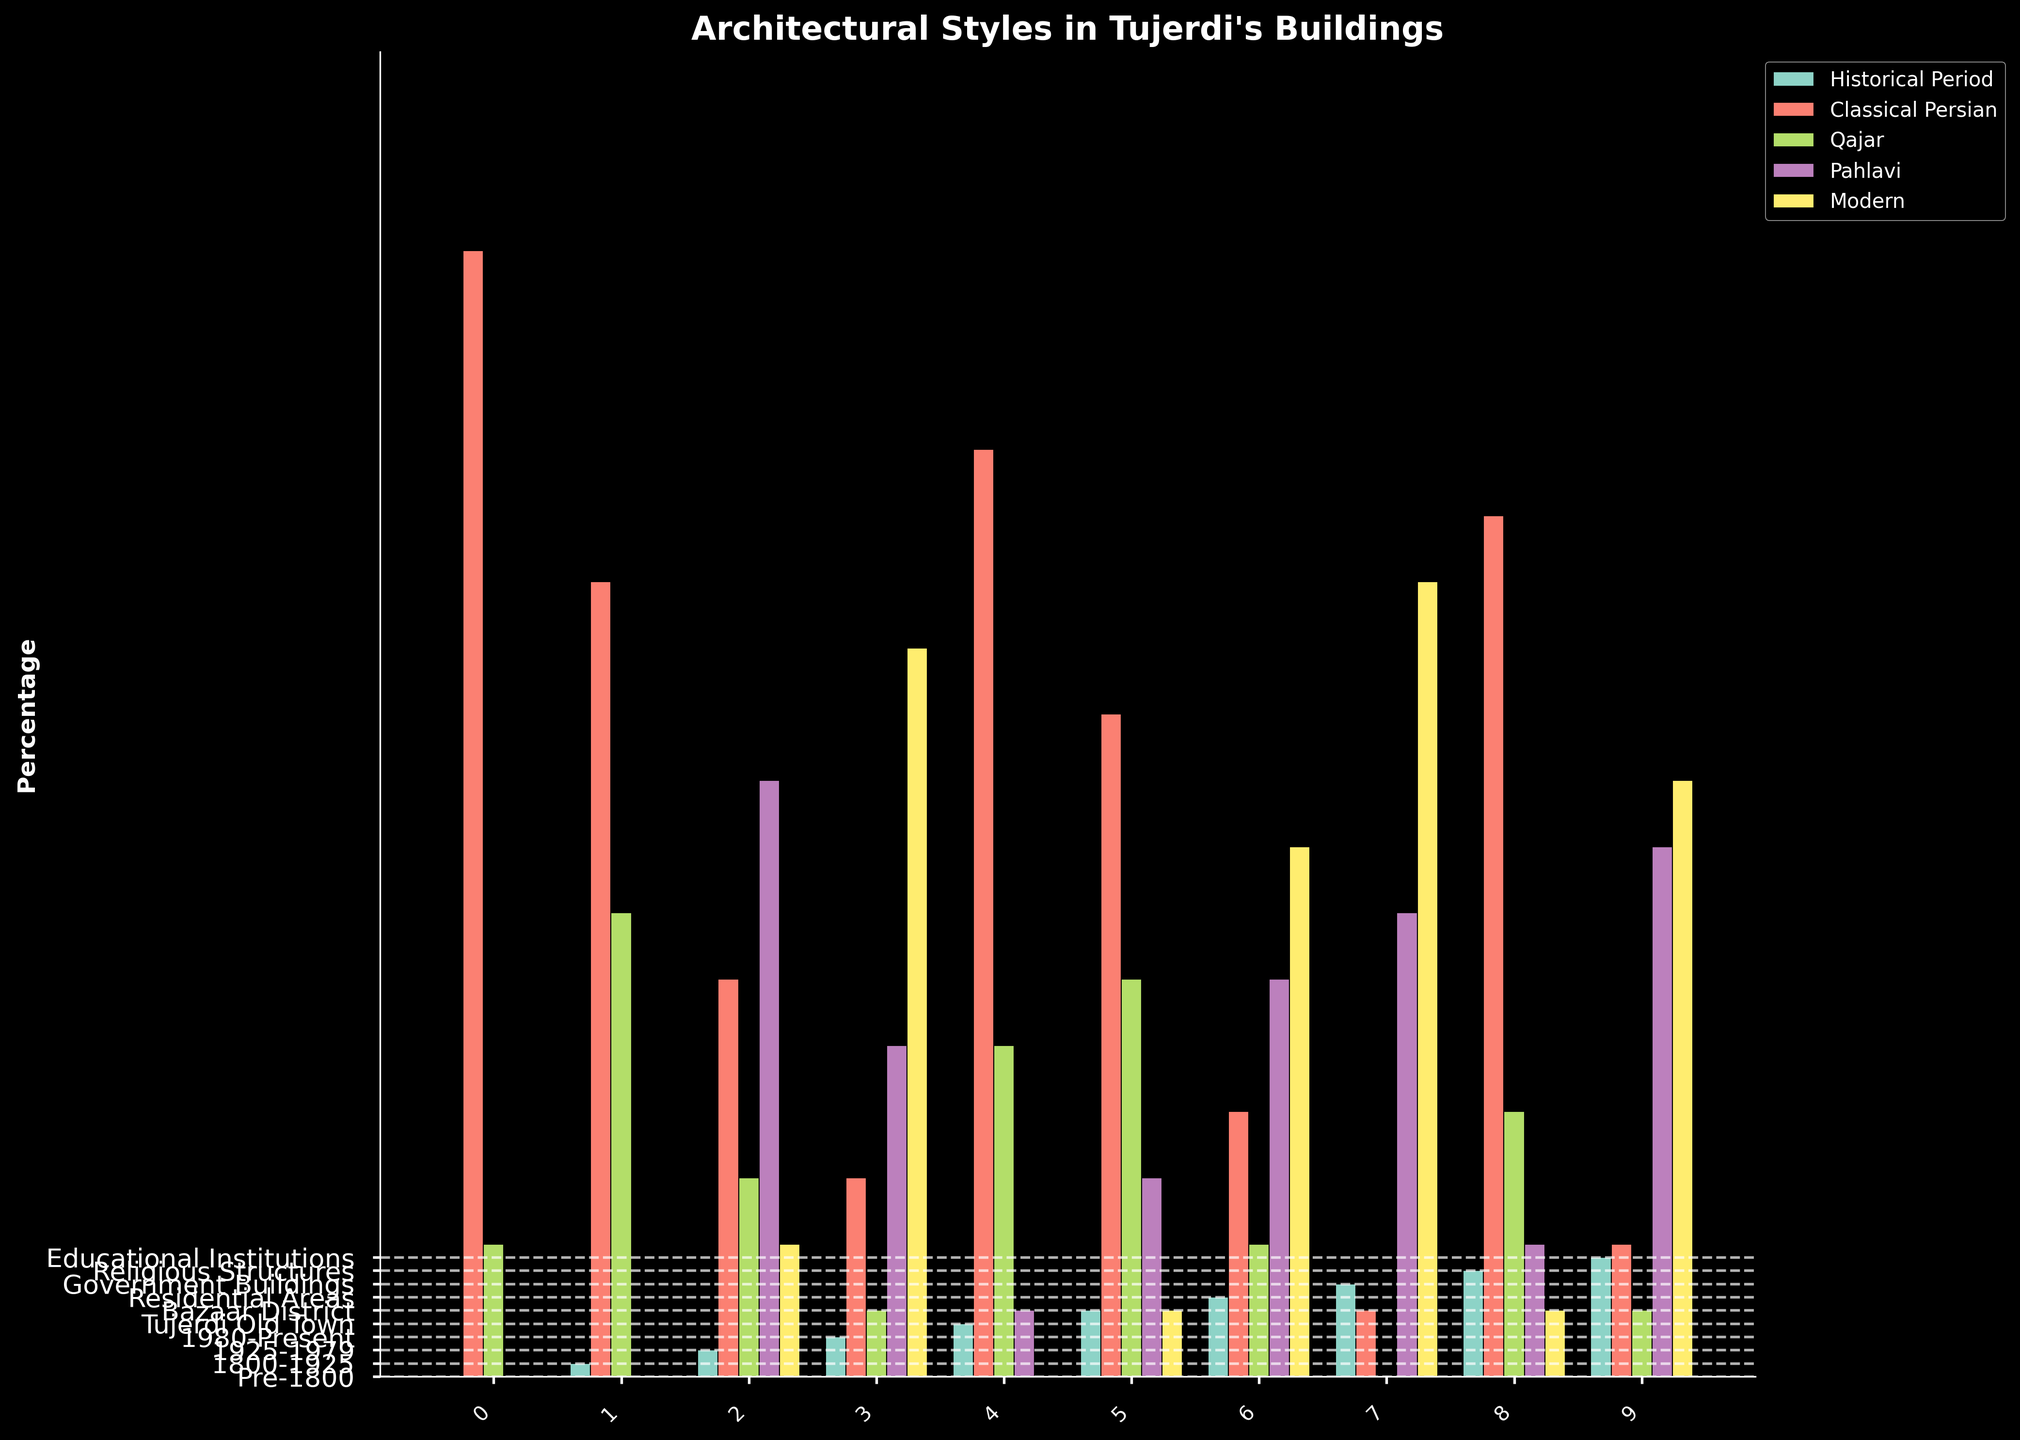Which historical period has the highest percentage of Classical Persian architecture? The bars representing Classical Persian architecture are colored distinctly. The bar for the Pre-1800 period is visibly the tallest among them, reaching 85%.
Answer: Pre-1800 What is the difference in the percentage of Modern style architecture between the 1980-Present and 1925-1979 periods? The Modern style bars for the 1980-Present (55%) and 1925-1979 (10%) periods must be compared. Subtract the latter from the former: 55% - 10%.
Answer: 45% Which location has the largest proportion of Pahlavi style buildings? The Pahlavi style buildings are marked in a specific color. The Government Buildings bar is the tallest, representing 35%.
Answer: Government Buildings Across all historical periods, which architectural style shows a decreasing trend over time? Observing the Classical Persian style bars, they decrease sequentially: Pre-1800 (85%), 1800-1925 (60%), 1925-1979 (30%), 1980-Present (15%).
Answer: Classical Persian How many periods show more than 30% of Qajar style architecture? Check each period’s Qajar style bar: Pre-1800 (10%), 1800-1925 (35%), 1925-1979 (15%), 1980-Present (5%). Only one period (1800-1925) has more than 30%.
Answer: 1 In the Residential Areas, what is the combined percentage of Classical Persian and Modern styles? Add the percentages for Classical Persian (20%) and Modern (40%): 20% + 40%.
Answer: 60% Which style has the smallest percentage of representation in the Tujerdi Old Town? The smallest bar in Tujerdi Old Town represents the Pahlavi style at 5%.
Answer: Pahlavi Compare the representation of modern architecture between Bazaar District and Government Buildings. Which has a higher percentage? The Modern style is visually distinct. The bar for Government Buildings (60%) is taller than that for Bazaar District (5%).
Answer: Government Buildings What is the average percentage of Educational Institutions adopting Pahlavi style architecture? We only have one data point for Educational Institutions using Pahlavi style, which is 40%.
Answer: 40% What percentage of Religious Structures are built in the Qajar style? The Qajar style bar for Religious Structures stands at 20%.
Answer: 20% 